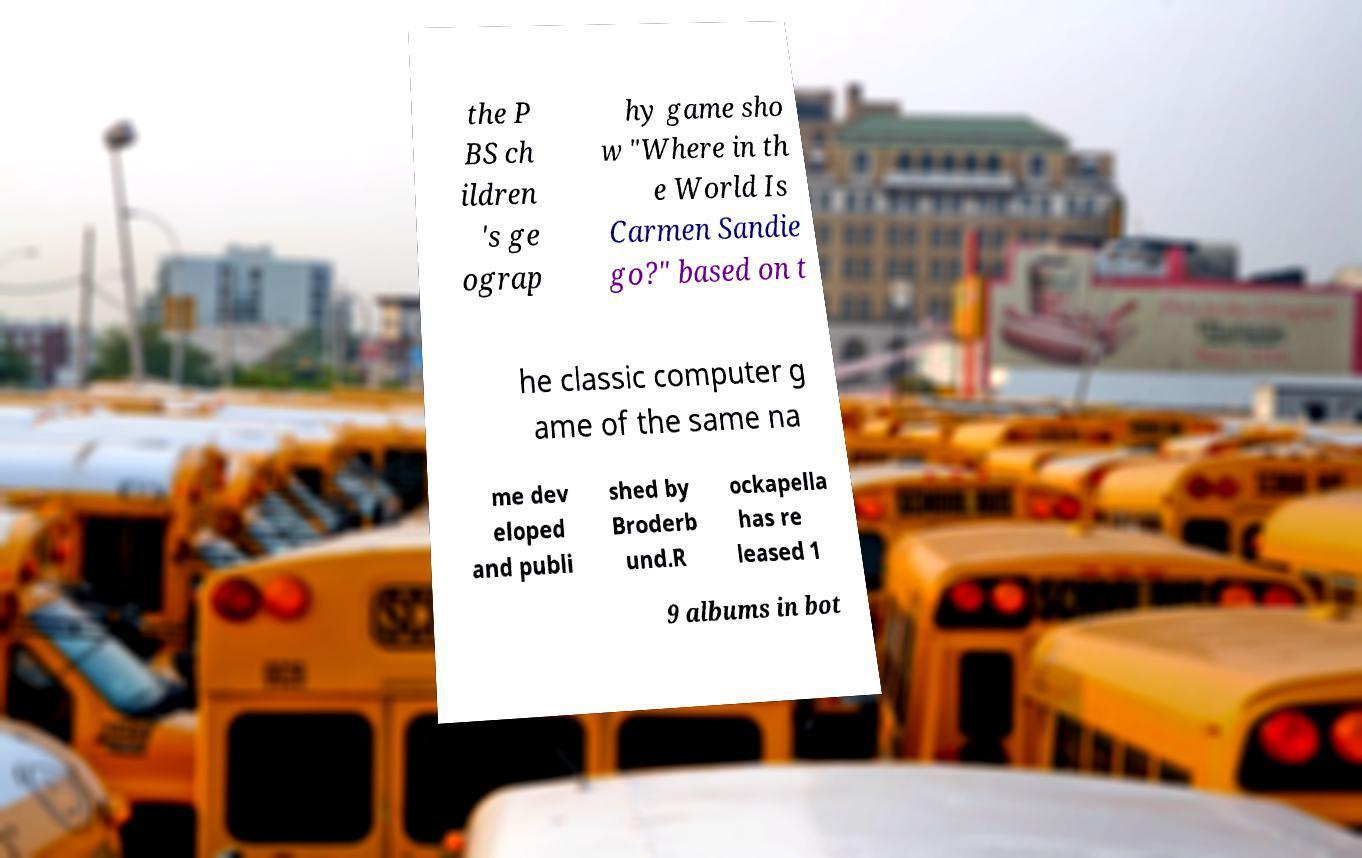Can you read and provide the text displayed in the image?This photo seems to have some interesting text. Can you extract and type it out for me? the P BS ch ildren 's ge ograp hy game sho w "Where in th e World Is Carmen Sandie go?" based on t he classic computer g ame of the same na me dev eloped and publi shed by Broderb und.R ockapella has re leased 1 9 albums in bot 